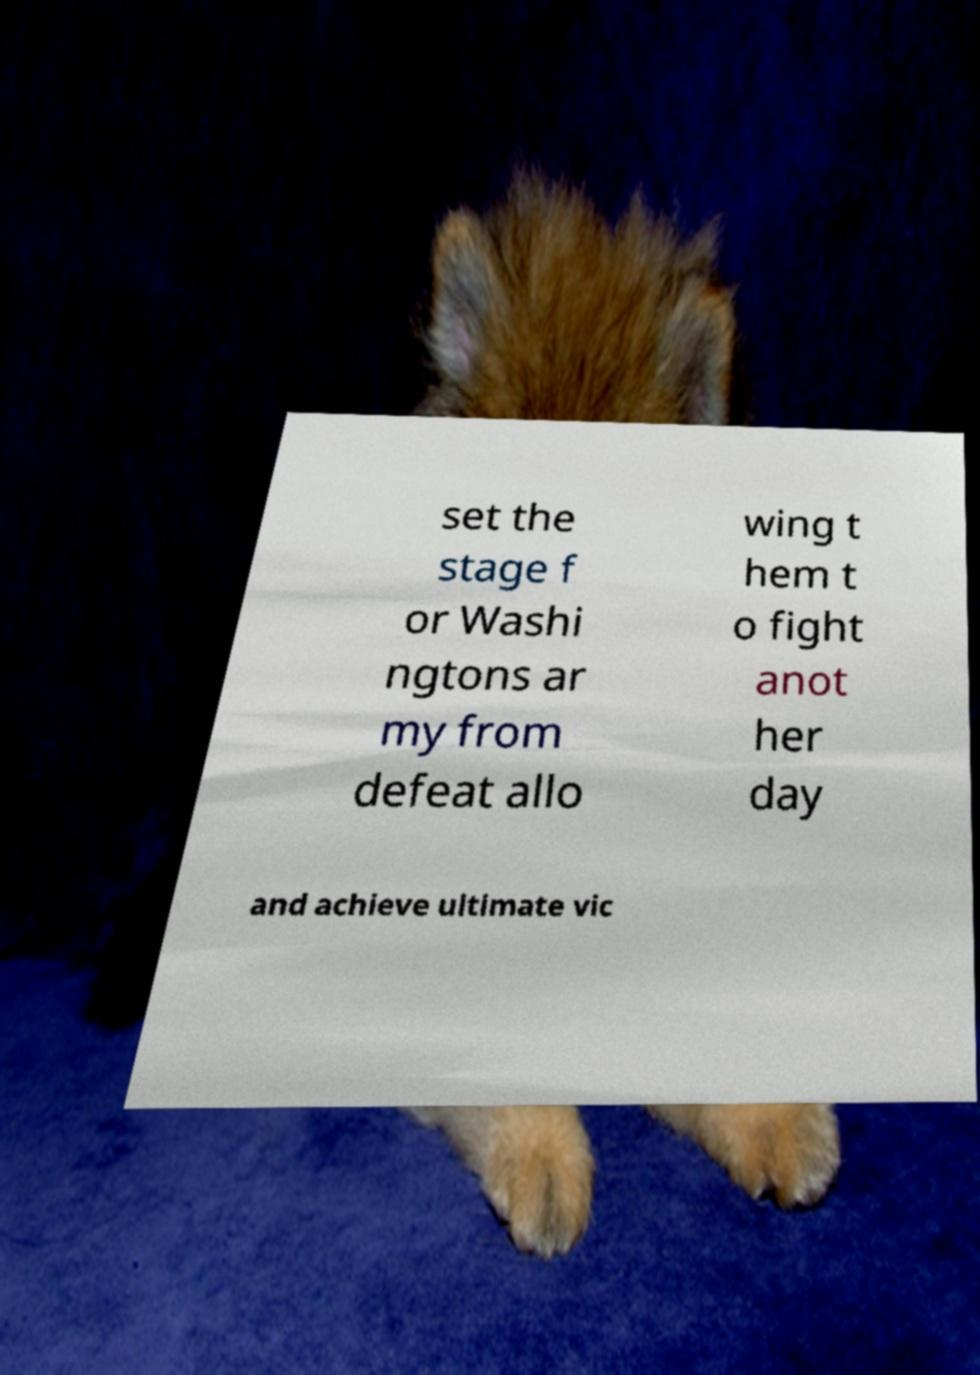Please identify and transcribe the text found in this image. set the stage f or Washi ngtons ar my from defeat allo wing t hem t o fight anot her day and achieve ultimate vic 